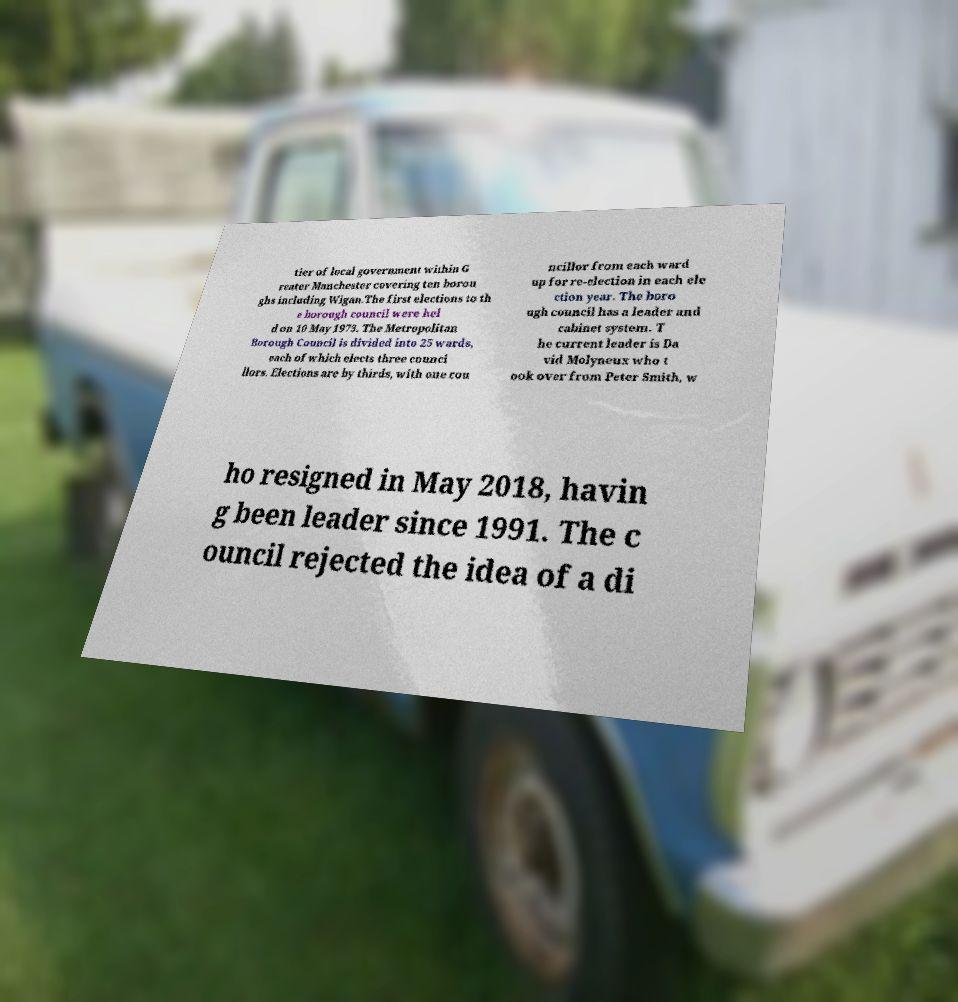Could you assist in decoding the text presented in this image and type it out clearly? tier of local government within G reater Manchester covering ten borou ghs including Wigan.The first elections to th e borough council were hel d on 10 May 1973. The Metropolitan Borough Council is divided into 25 wards, each of which elects three counci llors. Elections are by thirds, with one cou ncillor from each ward up for re-election in each ele ction year. The boro ugh council has a leader and cabinet system. T he current leader is Da vid Molyneux who t ook over from Peter Smith, w ho resigned in May 2018, havin g been leader since 1991. The c ouncil rejected the idea of a di 